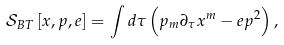Convert formula to latex. <formula><loc_0><loc_0><loc_500><loc_500>\mathcal { S } _ { B T } \left [ x , p , e \right ] = \int d \tau \left ( p _ { m } \partial _ { \tau } x ^ { m } - e p ^ { 2 } \right ) ,</formula> 